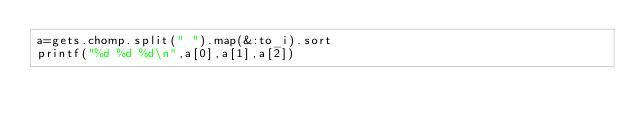<code> <loc_0><loc_0><loc_500><loc_500><_Ruby_>a=gets.chomp.split(" ").map(&:to_i).sort
printf("%d %d %d\n",a[0],a[1],a[2])</code> 